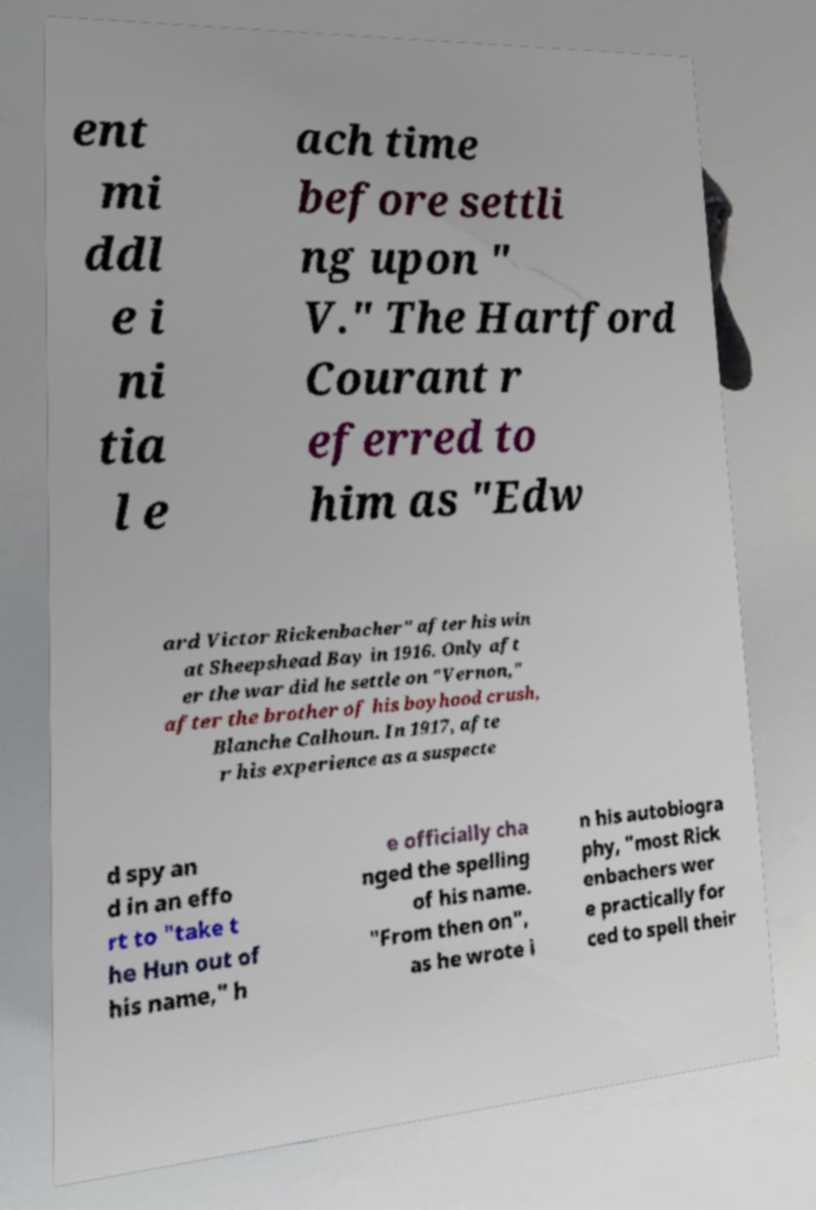Can you accurately transcribe the text from the provided image for me? ent mi ddl e i ni tia l e ach time before settli ng upon " V." The Hartford Courant r eferred to him as "Edw ard Victor Rickenbacher" after his win at Sheepshead Bay in 1916. Only aft er the war did he settle on "Vernon," after the brother of his boyhood crush, Blanche Calhoun. In 1917, afte r his experience as a suspecte d spy an d in an effo rt to "take t he Hun out of his name," h e officially cha nged the spelling of his name. "From then on", as he wrote i n his autobiogra phy, "most Rick enbachers wer e practically for ced to spell their 